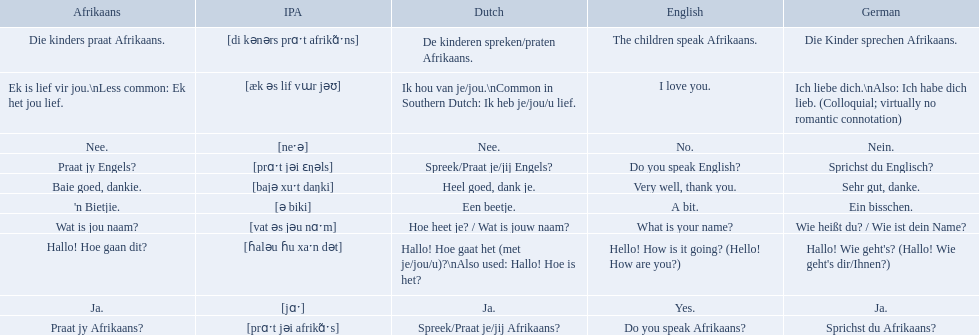Which phrases are said in africaans? Hallo! Hoe gaan dit?, Baie goed, dankie., Praat jy Afrikaans?, Praat jy Engels?, Ja., Nee., 'n Bietjie., Wat is jou naam?, Die kinders praat Afrikaans., Ek is lief vir jou.\nLess common: Ek het jou lief. Which of these mean how do you speak afrikaans? Praat jy Afrikaans?. 